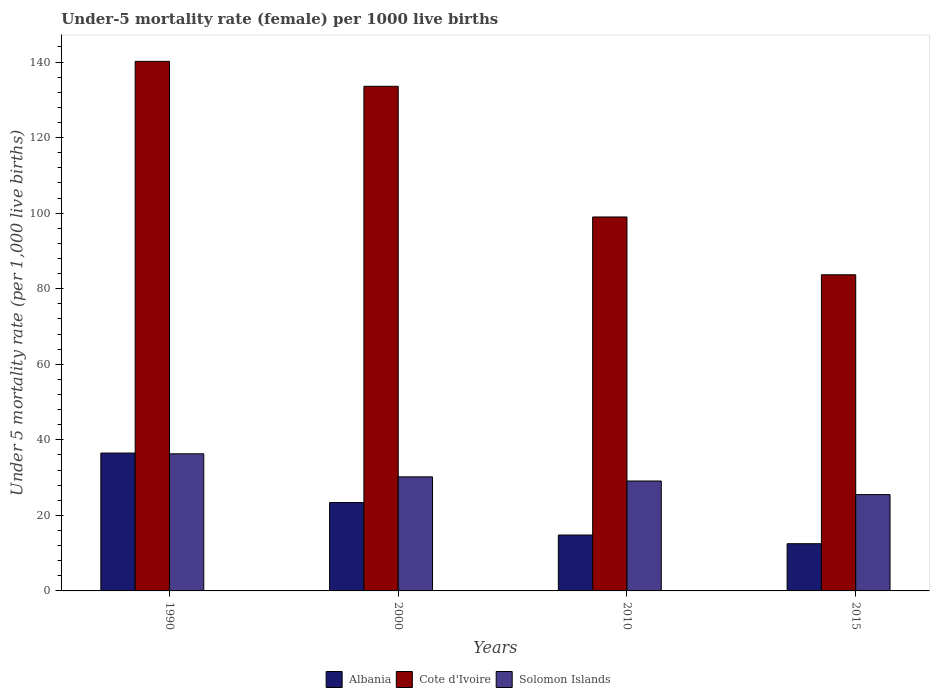How many different coloured bars are there?
Give a very brief answer. 3. Are the number of bars per tick equal to the number of legend labels?
Offer a terse response. Yes. How many bars are there on the 2nd tick from the right?
Ensure brevity in your answer.  3. What is the label of the 2nd group of bars from the left?
Provide a succinct answer. 2000. What is the under-five mortality rate in Solomon Islands in 2000?
Offer a terse response. 30.2. Across all years, what is the maximum under-five mortality rate in Albania?
Your answer should be very brief. 36.5. In which year was the under-five mortality rate in Albania maximum?
Offer a very short reply. 1990. In which year was the under-five mortality rate in Albania minimum?
Ensure brevity in your answer.  2015. What is the total under-five mortality rate in Albania in the graph?
Offer a terse response. 87.2. What is the difference between the under-five mortality rate in Cote d'Ivoire in 1990 and that in 2010?
Keep it short and to the point. 41.2. What is the difference between the under-five mortality rate in Solomon Islands in 2000 and the under-five mortality rate in Cote d'Ivoire in 2010?
Give a very brief answer. -68.8. What is the average under-five mortality rate in Cote d'Ivoire per year?
Your answer should be compact. 114.12. In the year 2000, what is the difference between the under-five mortality rate in Cote d'Ivoire and under-five mortality rate in Solomon Islands?
Offer a terse response. 103.4. In how many years, is the under-five mortality rate in Albania greater than 8?
Make the answer very short. 4. What is the ratio of the under-five mortality rate in Albania in 2000 to that in 2010?
Offer a very short reply. 1.58. Is the under-five mortality rate in Solomon Islands in 1990 less than that in 2015?
Offer a very short reply. No. Is the difference between the under-five mortality rate in Cote d'Ivoire in 1990 and 2000 greater than the difference between the under-five mortality rate in Solomon Islands in 1990 and 2000?
Your response must be concise. Yes. What is the difference between the highest and the second highest under-five mortality rate in Solomon Islands?
Provide a succinct answer. 6.1. What is the difference between the highest and the lowest under-five mortality rate in Solomon Islands?
Provide a short and direct response. 10.8. Is the sum of the under-five mortality rate in Solomon Islands in 1990 and 2000 greater than the maximum under-five mortality rate in Cote d'Ivoire across all years?
Offer a very short reply. No. What does the 1st bar from the left in 2015 represents?
Your response must be concise. Albania. What does the 3rd bar from the right in 2010 represents?
Keep it short and to the point. Albania. How many bars are there?
Provide a short and direct response. 12. Are all the bars in the graph horizontal?
Keep it short and to the point. No. What is the difference between two consecutive major ticks on the Y-axis?
Provide a succinct answer. 20. Does the graph contain any zero values?
Keep it short and to the point. No. Does the graph contain grids?
Make the answer very short. No. How many legend labels are there?
Offer a very short reply. 3. How are the legend labels stacked?
Your answer should be very brief. Horizontal. What is the title of the graph?
Your answer should be compact. Under-5 mortality rate (female) per 1000 live births. Does "Channel Islands" appear as one of the legend labels in the graph?
Offer a terse response. No. What is the label or title of the Y-axis?
Give a very brief answer. Under 5 mortality rate (per 1,0 live births). What is the Under 5 mortality rate (per 1,000 live births) in Albania in 1990?
Provide a short and direct response. 36.5. What is the Under 5 mortality rate (per 1,000 live births) in Cote d'Ivoire in 1990?
Ensure brevity in your answer.  140.2. What is the Under 5 mortality rate (per 1,000 live births) of Solomon Islands in 1990?
Offer a very short reply. 36.3. What is the Under 5 mortality rate (per 1,000 live births) of Albania in 2000?
Offer a very short reply. 23.4. What is the Under 5 mortality rate (per 1,000 live births) in Cote d'Ivoire in 2000?
Provide a short and direct response. 133.6. What is the Under 5 mortality rate (per 1,000 live births) in Solomon Islands in 2000?
Provide a short and direct response. 30.2. What is the Under 5 mortality rate (per 1,000 live births) in Albania in 2010?
Your response must be concise. 14.8. What is the Under 5 mortality rate (per 1,000 live births) of Cote d'Ivoire in 2010?
Ensure brevity in your answer.  99. What is the Under 5 mortality rate (per 1,000 live births) of Solomon Islands in 2010?
Provide a short and direct response. 29.1. What is the Under 5 mortality rate (per 1,000 live births) in Cote d'Ivoire in 2015?
Provide a succinct answer. 83.7. Across all years, what is the maximum Under 5 mortality rate (per 1,000 live births) of Albania?
Offer a terse response. 36.5. Across all years, what is the maximum Under 5 mortality rate (per 1,000 live births) of Cote d'Ivoire?
Offer a terse response. 140.2. Across all years, what is the maximum Under 5 mortality rate (per 1,000 live births) in Solomon Islands?
Offer a terse response. 36.3. Across all years, what is the minimum Under 5 mortality rate (per 1,000 live births) of Cote d'Ivoire?
Keep it short and to the point. 83.7. Across all years, what is the minimum Under 5 mortality rate (per 1,000 live births) in Solomon Islands?
Your answer should be very brief. 25.5. What is the total Under 5 mortality rate (per 1,000 live births) of Albania in the graph?
Your answer should be very brief. 87.2. What is the total Under 5 mortality rate (per 1,000 live births) in Cote d'Ivoire in the graph?
Your answer should be compact. 456.5. What is the total Under 5 mortality rate (per 1,000 live births) in Solomon Islands in the graph?
Make the answer very short. 121.1. What is the difference between the Under 5 mortality rate (per 1,000 live births) in Albania in 1990 and that in 2000?
Offer a very short reply. 13.1. What is the difference between the Under 5 mortality rate (per 1,000 live births) in Cote d'Ivoire in 1990 and that in 2000?
Your answer should be very brief. 6.6. What is the difference between the Under 5 mortality rate (per 1,000 live births) of Albania in 1990 and that in 2010?
Your answer should be very brief. 21.7. What is the difference between the Under 5 mortality rate (per 1,000 live births) of Cote d'Ivoire in 1990 and that in 2010?
Keep it short and to the point. 41.2. What is the difference between the Under 5 mortality rate (per 1,000 live births) in Cote d'Ivoire in 1990 and that in 2015?
Keep it short and to the point. 56.5. What is the difference between the Under 5 mortality rate (per 1,000 live births) of Cote d'Ivoire in 2000 and that in 2010?
Give a very brief answer. 34.6. What is the difference between the Under 5 mortality rate (per 1,000 live births) in Solomon Islands in 2000 and that in 2010?
Provide a succinct answer. 1.1. What is the difference between the Under 5 mortality rate (per 1,000 live births) in Cote d'Ivoire in 2000 and that in 2015?
Ensure brevity in your answer.  49.9. What is the difference between the Under 5 mortality rate (per 1,000 live births) in Cote d'Ivoire in 2010 and that in 2015?
Your answer should be very brief. 15.3. What is the difference between the Under 5 mortality rate (per 1,000 live births) in Solomon Islands in 2010 and that in 2015?
Your answer should be very brief. 3.6. What is the difference between the Under 5 mortality rate (per 1,000 live births) in Albania in 1990 and the Under 5 mortality rate (per 1,000 live births) in Cote d'Ivoire in 2000?
Make the answer very short. -97.1. What is the difference between the Under 5 mortality rate (per 1,000 live births) of Albania in 1990 and the Under 5 mortality rate (per 1,000 live births) of Solomon Islands in 2000?
Offer a terse response. 6.3. What is the difference between the Under 5 mortality rate (per 1,000 live births) in Cote d'Ivoire in 1990 and the Under 5 mortality rate (per 1,000 live births) in Solomon Islands in 2000?
Make the answer very short. 110. What is the difference between the Under 5 mortality rate (per 1,000 live births) of Albania in 1990 and the Under 5 mortality rate (per 1,000 live births) of Cote d'Ivoire in 2010?
Make the answer very short. -62.5. What is the difference between the Under 5 mortality rate (per 1,000 live births) in Cote d'Ivoire in 1990 and the Under 5 mortality rate (per 1,000 live births) in Solomon Islands in 2010?
Offer a terse response. 111.1. What is the difference between the Under 5 mortality rate (per 1,000 live births) of Albania in 1990 and the Under 5 mortality rate (per 1,000 live births) of Cote d'Ivoire in 2015?
Your answer should be very brief. -47.2. What is the difference between the Under 5 mortality rate (per 1,000 live births) of Cote d'Ivoire in 1990 and the Under 5 mortality rate (per 1,000 live births) of Solomon Islands in 2015?
Your answer should be very brief. 114.7. What is the difference between the Under 5 mortality rate (per 1,000 live births) of Albania in 2000 and the Under 5 mortality rate (per 1,000 live births) of Cote d'Ivoire in 2010?
Your answer should be very brief. -75.6. What is the difference between the Under 5 mortality rate (per 1,000 live births) in Albania in 2000 and the Under 5 mortality rate (per 1,000 live births) in Solomon Islands in 2010?
Give a very brief answer. -5.7. What is the difference between the Under 5 mortality rate (per 1,000 live births) in Cote d'Ivoire in 2000 and the Under 5 mortality rate (per 1,000 live births) in Solomon Islands in 2010?
Make the answer very short. 104.5. What is the difference between the Under 5 mortality rate (per 1,000 live births) in Albania in 2000 and the Under 5 mortality rate (per 1,000 live births) in Cote d'Ivoire in 2015?
Your response must be concise. -60.3. What is the difference between the Under 5 mortality rate (per 1,000 live births) of Cote d'Ivoire in 2000 and the Under 5 mortality rate (per 1,000 live births) of Solomon Islands in 2015?
Your response must be concise. 108.1. What is the difference between the Under 5 mortality rate (per 1,000 live births) in Albania in 2010 and the Under 5 mortality rate (per 1,000 live births) in Cote d'Ivoire in 2015?
Your answer should be very brief. -68.9. What is the difference between the Under 5 mortality rate (per 1,000 live births) in Albania in 2010 and the Under 5 mortality rate (per 1,000 live births) in Solomon Islands in 2015?
Provide a succinct answer. -10.7. What is the difference between the Under 5 mortality rate (per 1,000 live births) in Cote d'Ivoire in 2010 and the Under 5 mortality rate (per 1,000 live births) in Solomon Islands in 2015?
Offer a very short reply. 73.5. What is the average Under 5 mortality rate (per 1,000 live births) of Albania per year?
Give a very brief answer. 21.8. What is the average Under 5 mortality rate (per 1,000 live births) in Cote d'Ivoire per year?
Ensure brevity in your answer.  114.12. What is the average Under 5 mortality rate (per 1,000 live births) in Solomon Islands per year?
Your answer should be compact. 30.27. In the year 1990, what is the difference between the Under 5 mortality rate (per 1,000 live births) in Albania and Under 5 mortality rate (per 1,000 live births) in Cote d'Ivoire?
Keep it short and to the point. -103.7. In the year 1990, what is the difference between the Under 5 mortality rate (per 1,000 live births) of Albania and Under 5 mortality rate (per 1,000 live births) of Solomon Islands?
Your answer should be compact. 0.2. In the year 1990, what is the difference between the Under 5 mortality rate (per 1,000 live births) of Cote d'Ivoire and Under 5 mortality rate (per 1,000 live births) of Solomon Islands?
Provide a short and direct response. 103.9. In the year 2000, what is the difference between the Under 5 mortality rate (per 1,000 live births) of Albania and Under 5 mortality rate (per 1,000 live births) of Cote d'Ivoire?
Offer a very short reply. -110.2. In the year 2000, what is the difference between the Under 5 mortality rate (per 1,000 live births) of Cote d'Ivoire and Under 5 mortality rate (per 1,000 live births) of Solomon Islands?
Ensure brevity in your answer.  103.4. In the year 2010, what is the difference between the Under 5 mortality rate (per 1,000 live births) of Albania and Under 5 mortality rate (per 1,000 live births) of Cote d'Ivoire?
Make the answer very short. -84.2. In the year 2010, what is the difference between the Under 5 mortality rate (per 1,000 live births) in Albania and Under 5 mortality rate (per 1,000 live births) in Solomon Islands?
Keep it short and to the point. -14.3. In the year 2010, what is the difference between the Under 5 mortality rate (per 1,000 live births) in Cote d'Ivoire and Under 5 mortality rate (per 1,000 live births) in Solomon Islands?
Your answer should be compact. 69.9. In the year 2015, what is the difference between the Under 5 mortality rate (per 1,000 live births) of Albania and Under 5 mortality rate (per 1,000 live births) of Cote d'Ivoire?
Provide a short and direct response. -71.2. In the year 2015, what is the difference between the Under 5 mortality rate (per 1,000 live births) in Cote d'Ivoire and Under 5 mortality rate (per 1,000 live births) in Solomon Islands?
Provide a succinct answer. 58.2. What is the ratio of the Under 5 mortality rate (per 1,000 live births) in Albania in 1990 to that in 2000?
Provide a short and direct response. 1.56. What is the ratio of the Under 5 mortality rate (per 1,000 live births) in Cote d'Ivoire in 1990 to that in 2000?
Your response must be concise. 1.05. What is the ratio of the Under 5 mortality rate (per 1,000 live births) in Solomon Islands in 1990 to that in 2000?
Your response must be concise. 1.2. What is the ratio of the Under 5 mortality rate (per 1,000 live births) in Albania in 1990 to that in 2010?
Make the answer very short. 2.47. What is the ratio of the Under 5 mortality rate (per 1,000 live births) of Cote d'Ivoire in 1990 to that in 2010?
Give a very brief answer. 1.42. What is the ratio of the Under 5 mortality rate (per 1,000 live births) of Solomon Islands in 1990 to that in 2010?
Give a very brief answer. 1.25. What is the ratio of the Under 5 mortality rate (per 1,000 live births) in Albania in 1990 to that in 2015?
Your answer should be compact. 2.92. What is the ratio of the Under 5 mortality rate (per 1,000 live births) in Cote d'Ivoire in 1990 to that in 2015?
Offer a terse response. 1.68. What is the ratio of the Under 5 mortality rate (per 1,000 live births) of Solomon Islands in 1990 to that in 2015?
Offer a terse response. 1.42. What is the ratio of the Under 5 mortality rate (per 1,000 live births) of Albania in 2000 to that in 2010?
Offer a terse response. 1.58. What is the ratio of the Under 5 mortality rate (per 1,000 live births) of Cote d'Ivoire in 2000 to that in 2010?
Ensure brevity in your answer.  1.35. What is the ratio of the Under 5 mortality rate (per 1,000 live births) of Solomon Islands in 2000 to that in 2010?
Your response must be concise. 1.04. What is the ratio of the Under 5 mortality rate (per 1,000 live births) of Albania in 2000 to that in 2015?
Your response must be concise. 1.87. What is the ratio of the Under 5 mortality rate (per 1,000 live births) of Cote d'Ivoire in 2000 to that in 2015?
Offer a terse response. 1.6. What is the ratio of the Under 5 mortality rate (per 1,000 live births) of Solomon Islands in 2000 to that in 2015?
Your response must be concise. 1.18. What is the ratio of the Under 5 mortality rate (per 1,000 live births) of Albania in 2010 to that in 2015?
Make the answer very short. 1.18. What is the ratio of the Under 5 mortality rate (per 1,000 live births) in Cote d'Ivoire in 2010 to that in 2015?
Ensure brevity in your answer.  1.18. What is the ratio of the Under 5 mortality rate (per 1,000 live births) in Solomon Islands in 2010 to that in 2015?
Provide a short and direct response. 1.14. What is the difference between the highest and the second highest Under 5 mortality rate (per 1,000 live births) of Albania?
Provide a short and direct response. 13.1. What is the difference between the highest and the second highest Under 5 mortality rate (per 1,000 live births) in Cote d'Ivoire?
Provide a short and direct response. 6.6. What is the difference between the highest and the lowest Under 5 mortality rate (per 1,000 live births) of Albania?
Provide a succinct answer. 24. What is the difference between the highest and the lowest Under 5 mortality rate (per 1,000 live births) in Cote d'Ivoire?
Your answer should be compact. 56.5. 